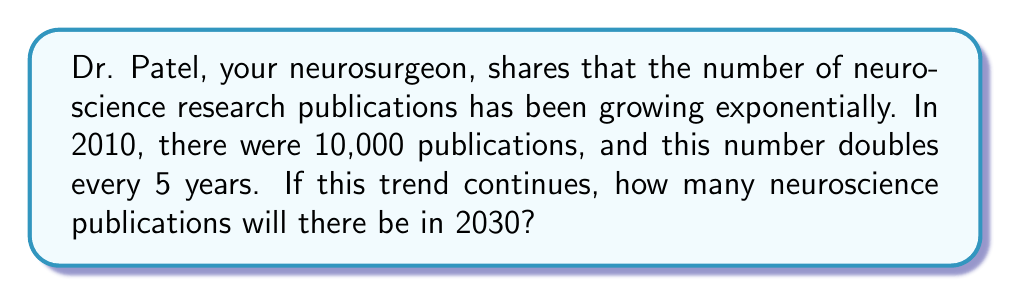Can you solve this math problem? Let's approach this step-by-step:

1) We start with 10,000 publications in 2010.
2) The number doubles every 5 years.
3) We need to find the number of publications after 20 years (from 2010 to 2030).

Let's use the exponential growth formula:
$$ A = P(1+r)^n $$
Where:
$A$ = final amount
$P$ = initial amount (10,000)
$r$ = growth rate (doubling every 5 years means 100% growth per 5 years, or $r = 1$)
$n$ = number of 5-year periods (4, as 20 years divided by 5)

Substituting these values:

$$ A = 10,000(1+1)^4 $$

Simplifying:
$$ A = 10,000(2)^4 $$
$$ A = 10,000 \cdot 16 $$
$$ A = 160,000 $$

Therefore, in 2030, there will be 160,000 neuroscience publications.
Answer: 160,000 publications 